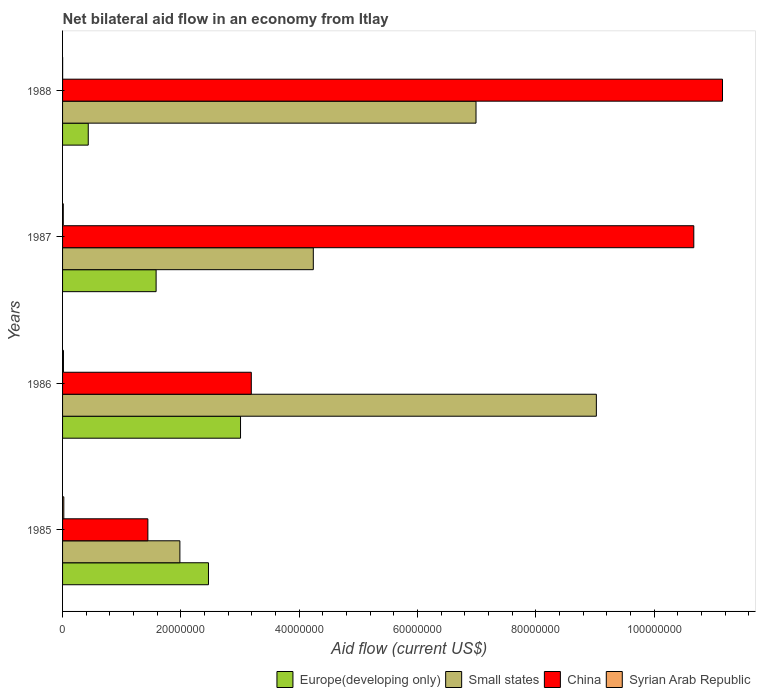How many different coloured bars are there?
Your response must be concise. 4. Are the number of bars on each tick of the Y-axis equal?
Keep it short and to the point. Yes. In how many cases, is the number of bars for a given year not equal to the number of legend labels?
Give a very brief answer. 0. What is the net bilateral aid flow in Small states in 1988?
Give a very brief answer. 6.99e+07. Across all years, what is the maximum net bilateral aid flow in Small states?
Offer a very short reply. 9.02e+07. Across all years, what is the minimum net bilateral aid flow in Europe(developing only)?
Your response must be concise. 4.34e+06. In which year was the net bilateral aid flow in Small states minimum?
Provide a short and direct response. 1985. What is the total net bilateral aid flow in China in the graph?
Provide a short and direct response. 2.65e+08. What is the difference between the net bilateral aid flow in China in 1985 and that in 1988?
Provide a succinct answer. -9.71e+07. What is the difference between the net bilateral aid flow in Europe(developing only) in 1985 and the net bilateral aid flow in Syrian Arab Republic in 1986?
Your answer should be very brief. 2.45e+07. What is the average net bilateral aid flow in Syrian Arab Republic per year?
Ensure brevity in your answer.  1.22e+05. In the year 1988, what is the difference between the net bilateral aid flow in China and net bilateral aid flow in Europe(developing only)?
Ensure brevity in your answer.  1.07e+08. In how many years, is the net bilateral aid flow in Syrian Arab Republic greater than 4000000 US$?
Offer a very short reply. 0. What is the ratio of the net bilateral aid flow in Small states in 1986 to that in 1987?
Your answer should be compact. 2.13. Is the net bilateral aid flow in Small states in 1987 less than that in 1988?
Keep it short and to the point. Yes. Is the difference between the net bilateral aid flow in China in 1986 and 1987 greater than the difference between the net bilateral aid flow in Europe(developing only) in 1986 and 1987?
Offer a terse response. No. What is the difference between the highest and the second highest net bilateral aid flow in Syrian Arab Republic?
Keep it short and to the point. 6.00e+04. What is the difference between the highest and the lowest net bilateral aid flow in Europe(developing only)?
Offer a terse response. 2.57e+07. Is the sum of the net bilateral aid flow in Small states in 1985 and 1986 greater than the maximum net bilateral aid flow in Syrian Arab Republic across all years?
Ensure brevity in your answer.  Yes. Is it the case that in every year, the sum of the net bilateral aid flow in Europe(developing only) and net bilateral aid flow in Syrian Arab Republic is greater than the sum of net bilateral aid flow in China and net bilateral aid flow in Small states?
Offer a very short reply. No. What does the 2nd bar from the top in 1988 represents?
Ensure brevity in your answer.  China. What does the 1st bar from the bottom in 1988 represents?
Your answer should be very brief. Europe(developing only). Are the values on the major ticks of X-axis written in scientific E-notation?
Give a very brief answer. No. Does the graph contain any zero values?
Offer a terse response. No. How many legend labels are there?
Your answer should be compact. 4. How are the legend labels stacked?
Your response must be concise. Horizontal. What is the title of the graph?
Offer a very short reply. Net bilateral aid flow in an economy from Itlay. Does "Sub-Saharan Africa (developing only)" appear as one of the legend labels in the graph?
Keep it short and to the point. No. What is the Aid flow (current US$) in Europe(developing only) in 1985?
Provide a succinct answer. 2.47e+07. What is the Aid flow (current US$) of Small states in 1985?
Offer a terse response. 1.98e+07. What is the Aid flow (current US$) in China in 1985?
Give a very brief answer. 1.44e+07. What is the Aid flow (current US$) of Europe(developing only) in 1986?
Provide a succinct answer. 3.01e+07. What is the Aid flow (current US$) of Small states in 1986?
Your answer should be compact. 9.02e+07. What is the Aid flow (current US$) in China in 1986?
Provide a succinct answer. 3.19e+07. What is the Aid flow (current US$) of Syrian Arab Republic in 1986?
Offer a very short reply. 1.50e+05. What is the Aid flow (current US$) of Europe(developing only) in 1987?
Your answer should be compact. 1.58e+07. What is the Aid flow (current US$) of Small states in 1987?
Provide a short and direct response. 4.24e+07. What is the Aid flow (current US$) of China in 1987?
Offer a very short reply. 1.07e+08. What is the Aid flow (current US$) of Syrian Arab Republic in 1987?
Make the answer very short. 1.20e+05. What is the Aid flow (current US$) of Europe(developing only) in 1988?
Keep it short and to the point. 4.34e+06. What is the Aid flow (current US$) of Small states in 1988?
Provide a succinct answer. 6.99e+07. What is the Aid flow (current US$) of China in 1988?
Keep it short and to the point. 1.12e+08. What is the Aid flow (current US$) in Syrian Arab Republic in 1988?
Your answer should be very brief. 10000. Across all years, what is the maximum Aid flow (current US$) of Europe(developing only)?
Your answer should be very brief. 3.01e+07. Across all years, what is the maximum Aid flow (current US$) in Small states?
Your answer should be compact. 9.02e+07. Across all years, what is the maximum Aid flow (current US$) in China?
Provide a succinct answer. 1.12e+08. Across all years, what is the maximum Aid flow (current US$) in Syrian Arab Republic?
Provide a short and direct response. 2.10e+05. Across all years, what is the minimum Aid flow (current US$) in Europe(developing only)?
Give a very brief answer. 4.34e+06. Across all years, what is the minimum Aid flow (current US$) of Small states?
Make the answer very short. 1.98e+07. Across all years, what is the minimum Aid flow (current US$) of China?
Make the answer very short. 1.44e+07. Across all years, what is the minimum Aid flow (current US$) in Syrian Arab Republic?
Your response must be concise. 10000. What is the total Aid flow (current US$) in Europe(developing only) in the graph?
Offer a very short reply. 7.49e+07. What is the total Aid flow (current US$) in Small states in the graph?
Provide a succinct answer. 2.22e+08. What is the total Aid flow (current US$) of China in the graph?
Ensure brevity in your answer.  2.65e+08. What is the total Aid flow (current US$) in Syrian Arab Republic in the graph?
Provide a succinct answer. 4.90e+05. What is the difference between the Aid flow (current US$) in Europe(developing only) in 1985 and that in 1986?
Your answer should be compact. -5.42e+06. What is the difference between the Aid flow (current US$) of Small states in 1985 and that in 1986?
Offer a very short reply. -7.04e+07. What is the difference between the Aid flow (current US$) of China in 1985 and that in 1986?
Offer a terse response. -1.75e+07. What is the difference between the Aid flow (current US$) in Europe(developing only) in 1985 and that in 1987?
Offer a terse response. 8.85e+06. What is the difference between the Aid flow (current US$) of Small states in 1985 and that in 1987?
Provide a succinct answer. -2.26e+07. What is the difference between the Aid flow (current US$) in China in 1985 and that in 1987?
Provide a short and direct response. -9.23e+07. What is the difference between the Aid flow (current US$) in Syrian Arab Republic in 1985 and that in 1987?
Make the answer very short. 9.00e+04. What is the difference between the Aid flow (current US$) of Europe(developing only) in 1985 and that in 1988?
Give a very brief answer. 2.03e+07. What is the difference between the Aid flow (current US$) in Small states in 1985 and that in 1988?
Your answer should be very brief. -5.00e+07. What is the difference between the Aid flow (current US$) in China in 1985 and that in 1988?
Offer a very short reply. -9.71e+07. What is the difference between the Aid flow (current US$) of Syrian Arab Republic in 1985 and that in 1988?
Your answer should be very brief. 2.00e+05. What is the difference between the Aid flow (current US$) of Europe(developing only) in 1986 and that in 1987?
Offer a terse response. 1.43e+07. What is the difference between the Aid flow (current US$) in Small states in 1986 and that in 1987?
Your answer should be very brief. 4.78e+07. What is the difference between the Aid flow (current US$) of China in 1986 and that in 1987?
Make the answer very short. -7.48e+07. What is the difference between the Aid flow (current US$) of Europe(developing only) in 1986 and that in 1988?
Ensure brevity in your answer.  2.57e+07. What is the difference between the Aid flow (current US$) in Small states in 1986 and that in 1988?
Give a very brief answer. 2.03e+07. What is the difference between the Aid flow (current US$) of China in 1986 and that in 1988?
Offer a very short reply. -7.96e+07. What is the difference between the Aid flow (current US$) of Syrian Arab Republic in 1986 and that in 1988?
Your answer should be very brief. 1.40e+05. What is the difference between the Aid flow (current US$) of Europe(developing only) in 1987 and that in 1988?
Your answer should be very brief. 1.15e+07. What is the difference between the Aid flow (current US$) in Small states in 1987 and that in 1988?
Your answer should be compact. -2.75e+07. What is the difference between the Aid flow (current US$) of China in 1987 and that in 1988?
Provide a short and direct response. -4.85e+06. What is the difference between the Aid flow (current US$) of Europe(developing only) in 1985 and the Aid flow (current US$) of Small states in 1986?
Ensure brevity in your answer.  -6.56e+07. What is the difference between the Aid flow (current US$) of Europe(developing only) in 1985 and the Aid flow (current US$) of China in 1986?
Offer a terse response. -7.24e+06. What is the difference between the Aid flow (current US$) of Europe(developing only) in 1985 and the Aid flow (current US$) of Syrian Arab Republic in 1986?
Your response must be concise. 2.45e+07. What is the difference between the Aid flow (current US$) of Small states in 1985 and the Aid flow (current US$) of China in 1986?
Provide a short and direct response. -1.21e+07. What is the difference between the Aid flow (current US$) of Small states in 1985 and the Aid flow (current US$) of Syrian Arab Republic in 1986?
Your answer should be very brief. 1.97e+07. What is the difference between the Aid flow (current US$) of China in 1985 and the Aid flow (current US$) of Syrian Arab Republic in 1986?
Give a very brief answer. 1.43e+07. What is the difference between the Aid flow (current US$) in Europe(developing only) in 1985 and the Aid flow (current US$) in Small states in 1987?
Provide a succinct answer. -1.77e+07. What is the difference between the Aid flow (current US$) in Europe(developing only) in 1985 and the Aid flow (current US$) in China in 1987?
Provide a succinct answer. -8.20e+07. What is the difference between the Aid flow (current US$) of Europe(developing only) in 1985 and the Aid flow (current US$) of Syrian Arab Republic in 1987?
Your response must be concise. 2.45e+07. What is the difference between the Aid flow (current US$) of Small states in 1985 and the Aid flow (current US$) of China in 1987?
Make the answer very short. -8.69e+07. What is the difference between the Aid flow (current US$) of Small states in 1985 and the Aid flow (current US$) of Syrian Arab Republic in 1987?
Give a very brief answer. 1.97e+07. What is the difference between the Aid flow (current US$) in China in 1985 and the Aid flow (current US$) in Syrian Arab Republic in 1987?
Your response must be concise. 1.43e+07. What is the difference between the Aid flow (current US$) in Europe(developing only) in 1985 and the Aid flow (current US$) in Small states in 1988?
Provide a short and direct response. -4.52e+07. What is the difference between the Aid flow (current US$) of Europe(developing only) in 1985 and the Aid flow (current US$) of China in 1988?
Keep it short and to the point. -8.69e+07. What is the difference between the Aid flow (current US$) in Europe(developing only) in 1985 and the Aid flow (current US$) in Syrian Arab Republic in 1988?
Your answer should be very brief. 2.46e+07. What is the difference between the Aid flow (current US$) of Small states in 1985 and the Aid flow (current US$) of China in 1988?
Offer a very short reply. -9.17e+07. What is the difference between the Aid flow (current US$) in Small states in 1985 and the Aid flow (current US$) in Syrian Arab Republic in 1988?
Keep it short and to the point. 1.98e+07. What is the difference between the Aid flow (current US$) in China in 1985 and the Aid flow (current US$) in Syrian Arab Republic in 1988?
Your answer should be very brief. 1.44e+07. What is the difference between the Aid flow (current US$) in Europe(developing only) in 1986 and the Aid flow (current US$) in Small states in 1987?
Your answer should be very brief. -1.23e+07. What is the difference between the Aid flow (current US$) in Europe(developing only) in 1986 and the Aid flow (current US$) in China in 1987?
Ensure brevity in your answer.  -7.66e+07. What is the difference between the Aid flow (current US$) in Europe(developing only) in 1986 and the Aid flow (current US$) in Syrian Arab Republic in 1987?
Provide a succinct answer. 3.00e+07. What is the difference between the Aid flow (current US$) in Small states in 1986 and the Aid flow (current US$) in China in 1987?
Offer a very short reply. -1.65e+07. What is the difference between the Aid flow (current US$) in Small states in 1986 and the Aid flow (current US$) in Syrian Arab Republic in 1987?
Your response must be concise. 9.01e+07. What is the difference between the Aid flow (current US$) in China in 1986 and the Aid flow (current US$) in Syrian Arab Republic in 1987?
Provide a succinct answer. 3.18e+07. What is the difference between the Aid flow (current US$) of Europe(developing only) in 1986 and the Aid flow (current US$) of Small states in 1988?
Your response must be concise. -3.98e+07. What is the difference between the Aid flow (current US$) of Europe(developing only) in 1986 and the Aid flow (current US$) of China in 1988?
Provide a short and direct response. -8.15e+07. What is the difference between the Aid flow (current US$) in Europe(developing only) in 1986 and the Aid flow (current US$) in Syrian Arab Republic in 1988?
Your answer should be very brief. 3.01e+07. What is the difference between the Aid flow (current US$) of Small states in 1986 and the Aid flow (current US$) of China in 1988?
Keep it short and to the point. -2.13e+07. What is the difference between the Aid flow (current US$) of Small states in 1986 and the Aid flow (current US$) of Syrian Arab Republic in 1988?
Offer a terse response. 9.02e+07. What is the difference between the Aid flow (current US$) in China in 1986 and the Aid flow (current US$) in Syrian Arab Republic in 1988?
Your answer should be very brief. 3.19e+07. What is the difference between the Aid flow (current US$) of Europe(developing only) in 1987 and the Aid flow (current US$) of Small states in 1988?
Make the answer very short. -5.41e+07. What is the difference between the Aid flow (current US$) of Europe(developing only) in 1987 and the Aid flow (current US$) of China in 1988?
Your answer should be compact. -9.57e+07. What is the difference between the Aid flow (current US$) of Europe(developing only) in 1987 and the Aid flow (current US$) of Syrian Arab Republic in 1988?
Offer a terse response. 1.58e+07. What is the difference between the Aid flow (current US$) of Small states in 1987 and the Aid flow (current US$) of China in 1988?
Provide a short and direct response. -6.92e+07. What is the difference between the Aid flow (current US$) in Small states in 1987 and the Aid flow (current US$) in Syrian Arab Republic in 1988?
Your answer should be compact. 4.24e+07. What is the difference between the Aid flow (current US$) of China in 1987 and the Aid flow (current US$) of Syrian Arab Republic in 1988?
Your answer should be very brief. 1.07e+08. What is the average Aid flow (current US$) of Europe(developing only) per year?
Your response must be concise. 1.87e+07. What is the average Aid flow (current US$) of Small states per year?
Offer a very short reply. 5.56e+07. What is the average Aid flow (current US$) in China per year?
Provide a succinct answer. 6.61e+07. What is the average Aid flow (current US$) in Syrian Arab Republic per year?
Your answer should be very brief. 1.22e+05. In the year 1985, what is the difference between the Aid flow (current US$) in Europe(developing only) and Aid flow (current US$) in Small states?
Ensure brevity in your answer.  4.83e+06. In the year 1985, what is the difference between the Aid flow (current US$) in Europe(developing only) and Aid flow (current US$) in China?
Keep it short and to the point. 1.02e+07. In the year 1985, what is the difference between the Aid flow (current US$) in Europe(developing only) and Aid flow (current US$) in Syrian Arab Republic?
Provide a succinct answer. 2.44e+07. In the year 1985, what is the difference between the Aid flow (current US$) of Small states and Aid flow (current US$) of China?
Provide a short and direct response. 5.41e+06. In the year 1985, what is the difference between the Aid flow (current US$) in Small states and Aid flow (current US$) in Syrian Arab Republic?
Your answer should be compact. 1.96e+07. In the year 1985, what is the difference between the Aid flow (current US$) of China and Aid flow (current US$) of Syrian Arab Republic?
Offer a very short reply. 1.42e+07. In the year 1986, what is the difference between the Aid flow (current US$) of Europe(developing only) and Aid flow (current US$) of Small states?
Make the answer very short. -6.01e+07. In the year 1986, what is the difference between the Aid flow (current US$) in Europe(developing only) and Aid flow (current US$) in China?
Your answer should be very brief. -1.82e+06. In the year 1986, what is the difference between the Aid flow (current US$) in Europe(developing only) and Aid flow (current US$) in Syrian Arab Republic?
Your response must be concise. 2.99e+07. In the year 1986, what is the difference between the Aid flow (current US$) in Small states and Aid flow (current US$) in China?
Ensure brevity in your answer.  5.83e+07. In the year 1986, what is the difference between the Aid flow (current US$) of Small states and Aid flow (current US$) of Syrian Arab Republic?
Your response must be concise. 9.01e+07. In the year 1986, what is the difference between the Aid flow (current US$) in China and Aid flow (current US$) in Syrian Arab Republic?
Make the answer very short. 3.18e+07. In the year 1987, what is the difference between the Aid flow (current US$) in Europe(developing only) and Aid flow (current US$) in Small states?
Offer a terse response. -2.66e+07. In the year 1987, what is the difference between the Aid flow (current US$) in Europe(developing only) and Aid flow (current US$) in China?
Make the answer very short. -9.09e+07. In the year 1987, what is the difference between the Aid flow (current US$) of Europe(developing only) and Aid flow (current US$) of Syrian Arab Republic?
Your answer should be very brief. 1.57e+07. In the year 1987, what is the difference between the Aid flow (current US$) of Small states and Aid flow (current US$) of China?
Ensure brevity in your answer.  -6.43e+07. In the year 1987, what is the difference between the Aid flow (current US$) in Small states and Aid flow (current US$) in Syrian Arab Republic?
Give a very brief answer. 4.23e+07. In the year 1987, what is the difference between the Aid flow (current US$) in China and Aid flow (current US$) in Syrian Arab Republic?
Provide a succinct answer. 1.07e+08. In the year 1988, what is the difference between the Aid flow (current US$) of Europe(developing only) and Aid flow (current US$) of Small states?
Your answer should be compact. -6.55e+07. In the year 1988, what is the difference between the Aid flow (current US$) in Europe(developing only) and Aid flow (current US$) in China?
Offer a terse response. -1.07e+08. In the year 1988, what is the difference between the Aid flow (current US$) of Europe(developing only) and Aid flow (current US$) of Syrian Arab Republic?
Your answer should be very brief. 4.33e+06. In the year 1988, what is the difference between the Aid flow (current US$) in Small states and Aid flow (current US$) in China?
Offer a very short reply. -4.17e+07. In the year 1988, what is the difference between the Aid flow (current US$) in Small states and Aid flow (current US$) in Syrian Arab Republic?
Offer a very short reply. 6.99e+07. In the year 1988, what is the difference between the Aid flow (current US$) of China and Aid flow (current US$) of Syrian Arab Republic?
Provide a short and direct response. 1.12e+08. What is the ratio of the Aid flow (current US$) of Europe(developing only) in 1985 to that in 1986?
Your response must be concise. 0.82. What is the ratio of the Aid flow (current US$) in Small states in 1985 to that in 1986?
Offer a very short reply. 0.22. What is the ratio of the Aid flow (current US$) in China in 1985 to that in 1986?
Offer a very short reply. 0.45. What is the ratio of the Aid flow (current US$) in Europe(developing only) in 1985 to that in 1987?
Provide a succinct answer. 1.56. What is the ratio of the Aid flow (current US$) of Small states in 1985 to that in 1987?
Your answer should be compact. 0.47. What is the ratio of the Aid flow (current US$) of China in 1985 to that in 1987?
Offer a very short reply. 0.14. What is the ratio of the Aid flow (current US$) of Syrian Arab Republic in 1985 to that in 1987?
Offer a very short reply. 1.75. What is the ratio of the Aid flow (current US$) in Europe(developing only) in 1985 to that in 1988?
Make the answer very short. 5.68. What is the ratio of the Aid flow (current US$) in Small states in 1985 to that in 1988?
Make the answer very short. 0.28. What is the ratio of the Aid flow (current US$) of China in 1985 to that in 1988?
Make the answer very short. 0.13. What is the ratio of the Aid flow (current US$) of Syrian Arab Republic in 1985 to that in 1988?
Ensure brevity in your answer.  21. What is the ratio of the Aid flow (current US$) in Europe(developing only) in 1986 to that in 1987?
Give a very brief answer. 1.9. What is the ratio of the Aid flow (current US$) of Small states in 1986 to that in 1987?
Your answer should be compact. 2.13. What is the ratio of the Aid flow (current US$) of China in 1986 to that in 1987?
Give a very brief answer. 0.3. What is the ratio of the Aid flow (current US$) in Syrian Arab Republic in 1986 to that in 1987?
Give a very brief answer. 1.25. What is the ratio of the Aid flow (current US$) in Europe(developing only) in 1986 to that in 1988?
Your response must be concise. 6.93. What is the ratio of the Aid flow (current US$) of Small states in 1986 to that in 1988?
Your answer should be very brief. 1.29. What is the ratio of the Aid flow (current US$) of China in 1986 to that in 1988?
Your answer should be very brief. 0.29. What is the ratio of the Aid flow (current US$) of Syrian Arab Republic in 1986 to that in 1988?
Give a very brief answer. 15. What is the ratio of the Aid flow (current US$) of Europe(developing only) in 1987 to that in 1988?
Provide a short and direct response. 3.64. What is the ratio of the Aid flow (current US$) in Small states in 1987 to that in 1988?
Ensure brevity in your answer.  0.61. What is the ratio of the Aid flow (current US$) in China in 1987 to that in 1988?
Your answer should be compact. 0.96. What is the ratio of the Aid flow (current US$) of Syrian Arab Republic in 1987 to that in 1988?
Give a very brief answer. 12. What is the difference between the highest and the second highest Aid flow (current US$) in Europe(developing only)?
Keep it short and to the point. 5.42e+06. What is the difference between the highest and the second highest Aid flow (current US$) of Small states?
Offer a terse response. 2.03e+07. What is the difference between the highest and the second highest Aid flow (current US$) in China?
Your answer should be compact. 4.85e+06. What is the difference between the highest and the lowest Aid flow (current US$) in Europe(developing only)?
Offer a terse response. 2.57e+07. What is the difference between the highest and the lowest Aid flow (current US$) of Small states?
Your response must be concise. 7.04e+07. What is the difference between the highest and the lowest Aid flow (current US$) of China?
Ensure brevity in your answer.  9.71e+07. 